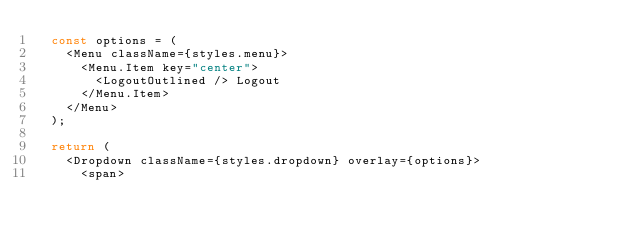Convert code to text. <code><loc_0><loc_0><loc_500><loc_500><_TypeScript_>  const options = (
    <Menu className={styles.menu}>
      <Menu.Item key="center">
        <LogoutOutlined /> Logout
      </Menu.Item>
    </Menu>
  );

  return (
    <Dropdown className={styles.dropdown} overlay={options}>
      <span></code> 